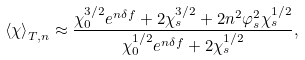Convert formula to latex. <formula><loc_0><loc_0><loc_500><loc_500>\left \langle \chi \right \rangle _ { T , n } \approx \frac { { \chi _ { 0 } ^ { 3 / 2 } e ^ { n \delta f } + 2 \chi _ { s } ^ { 3 / 2 } + 2 n ^ { 2 } \varphi _ { s } ^ { 2 } \chi _ { s } ^ { 1 / 2 } } } { { \chi _ { 0 } ^ { 1 / 2 } e ^ { n \delta f } + 2 \chi _ { s } ^ { 1 / 2 } } } ,</formula> 